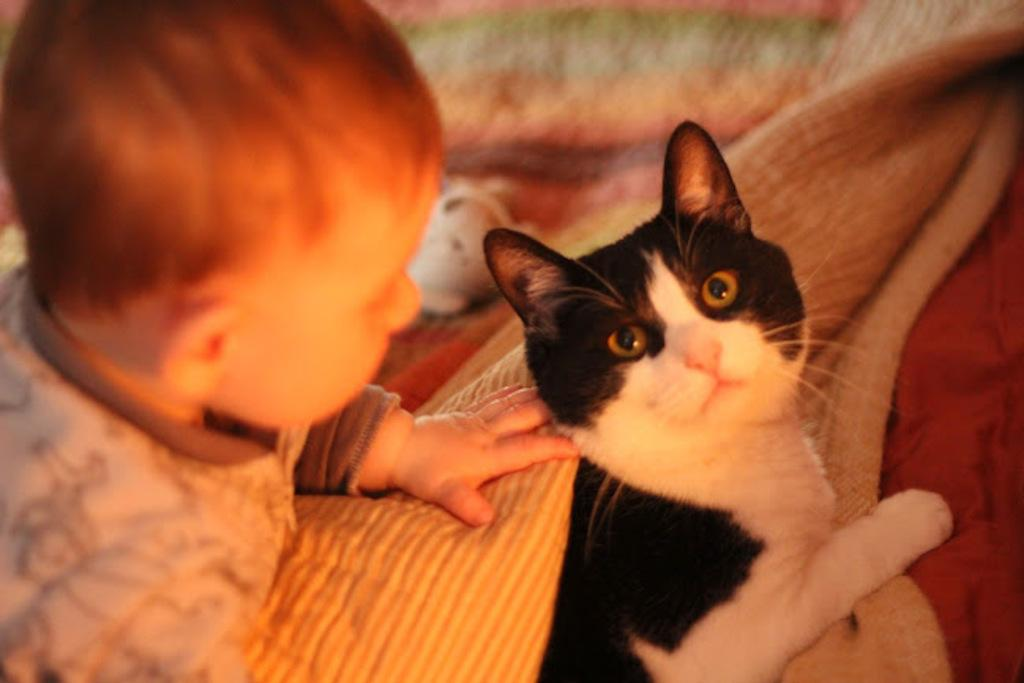What is the main subject of the image? The main subject of the image is a kid. Are there any animals present in the image? Yes, there is a black and white cat in the image. What type of pipe is the father using in the image? There is no father or pipe present in the image. 